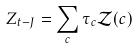Convert formula to latex. <formula><loc_0><loc_0><loc_500><loc_500>Z _ { t - J } = \sum _ { c } \tau _ { c } \mathcal { Z } ( c )</formula> 